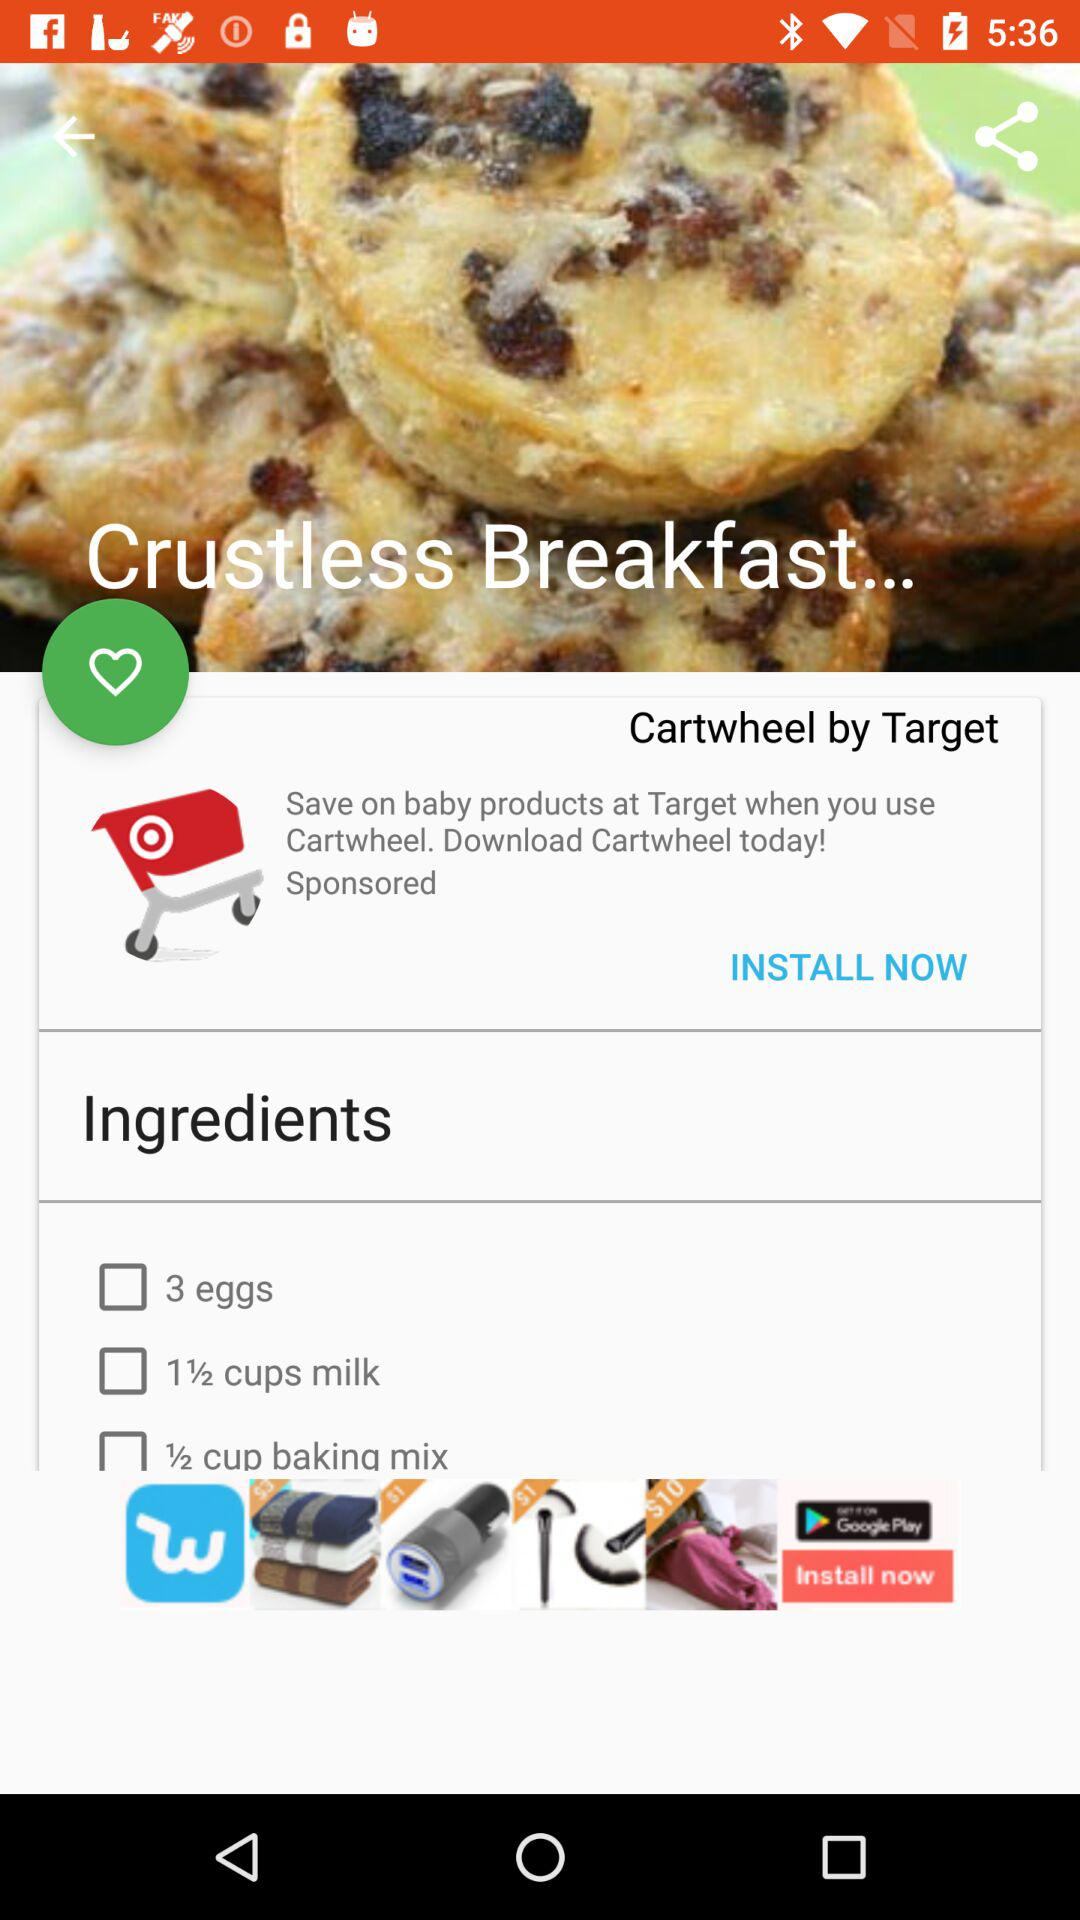How many eggs are required? There are 3 eggs required. 